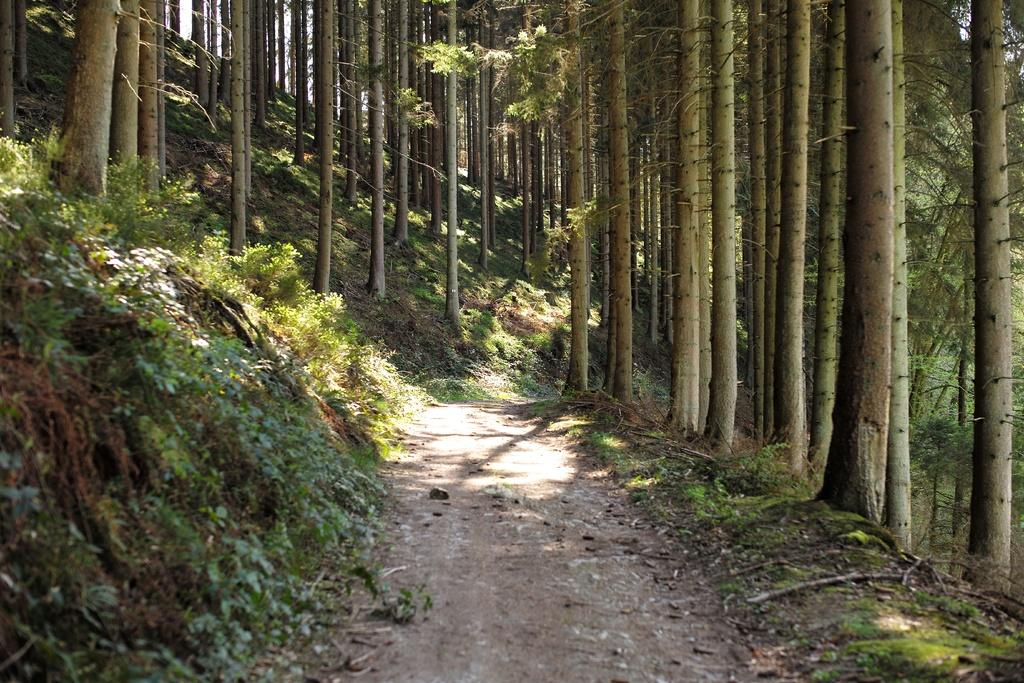What type of vegetation can be seen in the image? There are plants, grass, and trees visible in the image. What surface can be used for walking or traveling in the image? There is a path in the image that can be used for walking or traveling. What type of ghost can be seen hiding behind the trees in the image? There are no ghosts present in the image; it only features plants, grass, trees, and a path. 